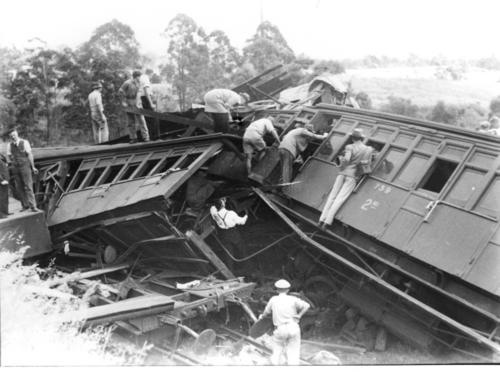Describe the objects in this image and their specific colors. I can see train in white, black, darkgray, gray, and lightgray tones, people in gainsboro, darkgray, gray, and white tones, people in white, darkgray, lightgray, gray, and black tones, people in white, gray, black, darkgray, and lightgray tones, and people in white, black, lightgray, gray, and darkgray tones in this image. 